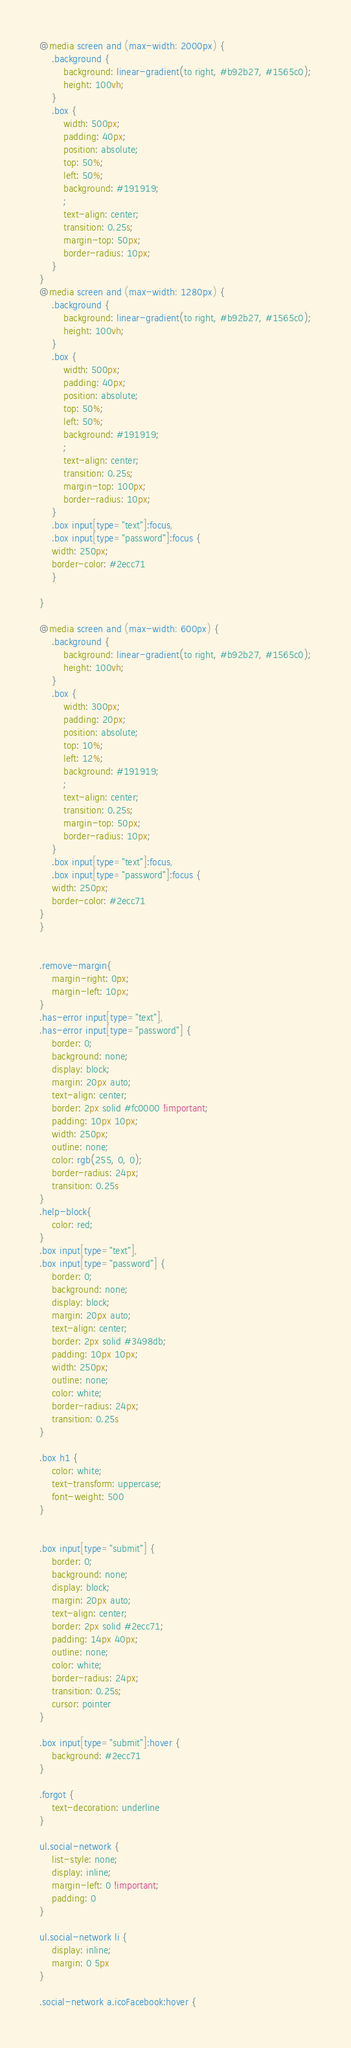Convert code to text. <code><loc_0><loc_0><loc_500><loc_500><_CSS_>@media screen and (max-width: 2000px) {
    .background {
        background: linear-gradient(to right, #b92b27, #1565c0);
        height: 100vh;
    }
    .box {
        width: 500px;
        padding: 40px;
        position: absolute;
        top: 50%;
        left: 50%;
        background: #191919;
        ;
        text-align: center;
        transition: 0.25s;
        margin-top: 50px;
        border-radius: 10px;
    }
}
@media screen and (max-width: 1280px) {
    .background {
        background: linear-gradient(to right, #b92b27, #1565c0);
        height: 100vh;
    }
    .box {
        width: 500px;
        padding: 40px;
        position: absolute;
        top: 50%;
        left: 50%;
        background: #191919;
        ;
        text-align: center;
        transition: 0.25s;
        margin-top: 100px;
        border-radius: 10px;
    }
    .box input[type="text"]:focus,
    .box input[type="password"]:focus {
    width: 250px;
    border-color: #2ecc71
    }

}

@media screen and (max-width: 600px) {
    .background {
        background: linear-gradient(to right, #b92b27, #1565c0);
        height: 100vh;
    }
    .box {
        width: 300px;
        padding: 20px;
        position: absolute;
        top: 10%;
        left: 12%;
        background: #191919;
        ;
        text-align: center;
        transition: 0.25s;
        margin-top: 50px;
        border-radius: 10px;
    }
    .box input[type="text"]:focus,
    .box input[type="password"]:focus {
    width: 250px;
    border-color: #2ecc71
}
}


.remove-margin{
    margin-right: 0px;
    margin-left: 10px;
}
.has-error input[type="text"],
.has-error input[type="password"] {
    border: 0;
    background: none;
    display: block;
    margin: 20px auto;
    text-align: center;
    border: 2px solid #fc0000 !important;
    padding: 10px 10px;
    width: 250px;
    outline: none;
    color: rgb(255, 0, 0);
    border-radius: 24px;
    transition: 0.25s
}
.help-block{
    color: red;
}
.box input[type="text"],
.box input[type="password"] {
    border: 0;
    background: none;
    display: block;
    margin: 20px auto;
    text-align: center;
    border: 2px solid #3498db;
    padding: 10px 10px;
    width: 250px;
    outline: none;
    color: white;
    border-radius: 24px;
    transition: 0.25s
}

.box h1 {
    color: white;
    text-transform: uppercase;
    font-weight: 500
}


.box input[type="submit"] {
    border: 0;
    background: none;
    display: block;
    margin: 20px auto;
    text-align: center;
    border: 2px solid #2ecc71;
    padding: 14px 40px;
    outline: none;
    color: white;
    border-radius: 24px;
    transition: 0.25s;
    cursor: pointer
}

.box input[type="submit"]:hover {
    background: #2ecc71
}

.forgot {
    text-decoration: underline
}

ul.social-network {
    list-style: none;
    display: inline;
    margin-left: 0 !important;
    padding: 0
}

ul.social-network li {
    display: inline;
    margin: 0 5px
}

.social-network a.icoFacebook:hover {</code> 